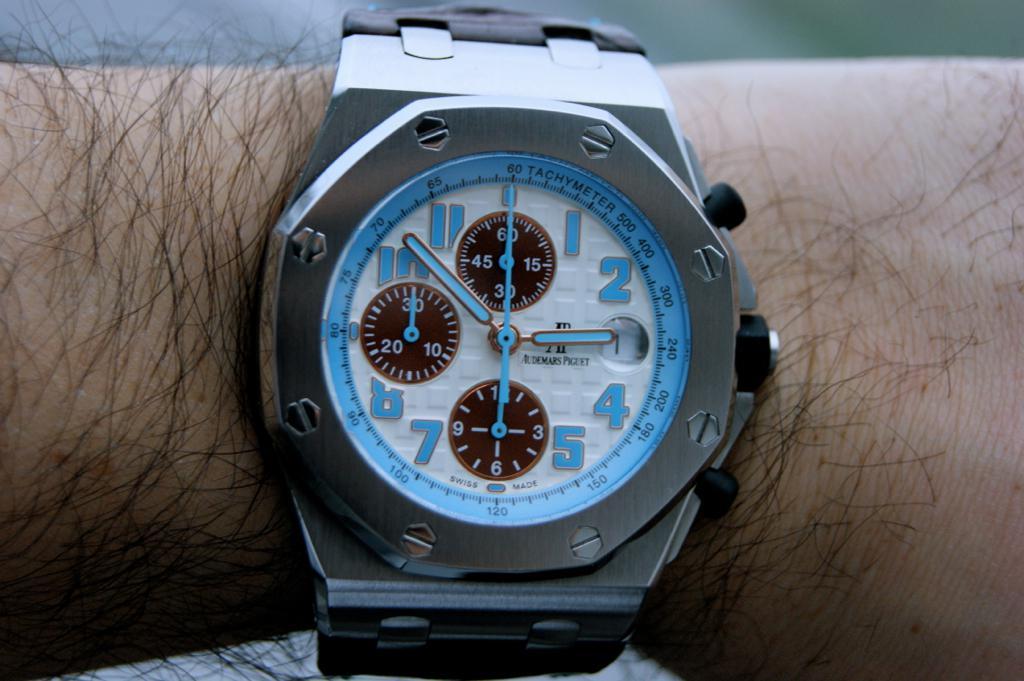What time is it?
Provide a short and direct response. 2:52. What number can be seen at the very top of the watch face?
Provide a short and direct response. 60. 